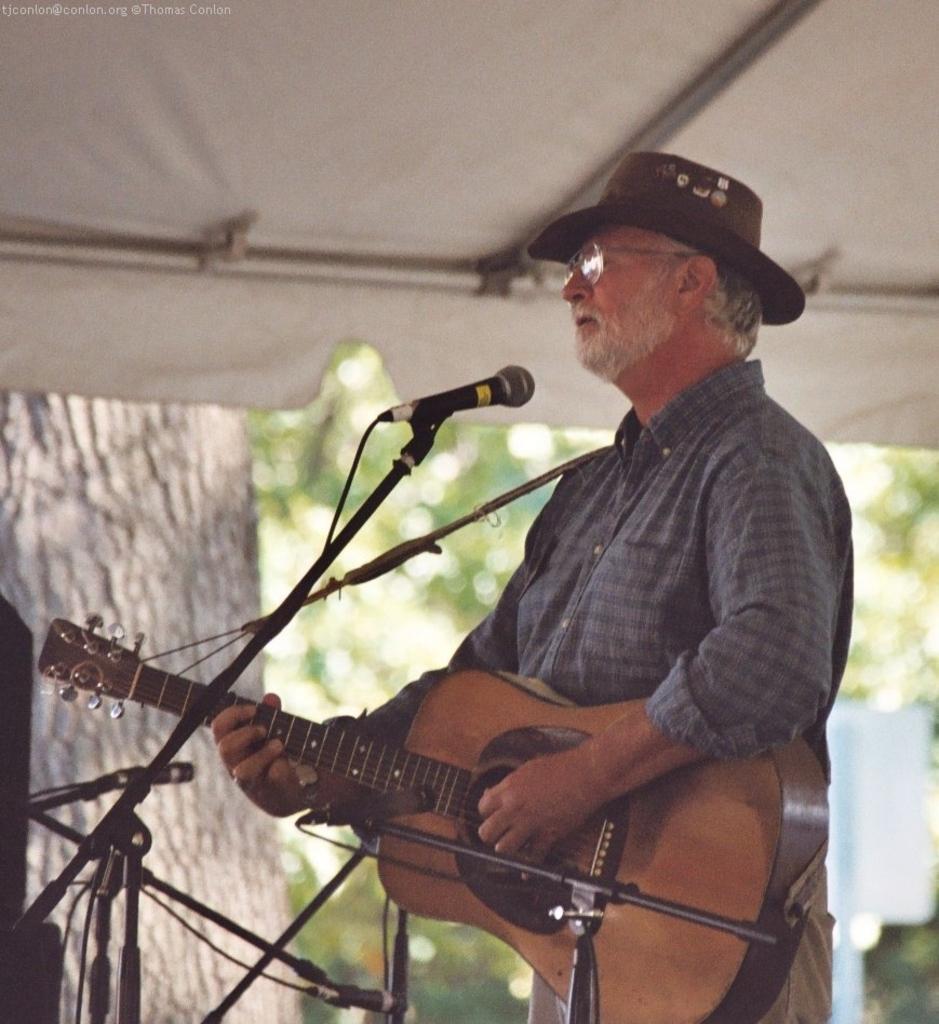Could you give a brief overview of what you see in this image? This picture shows a man standing and playing guitar in his hands. He is wearing hat. He is standing in front of a mic and a stand. In the background, there are some trees here. 